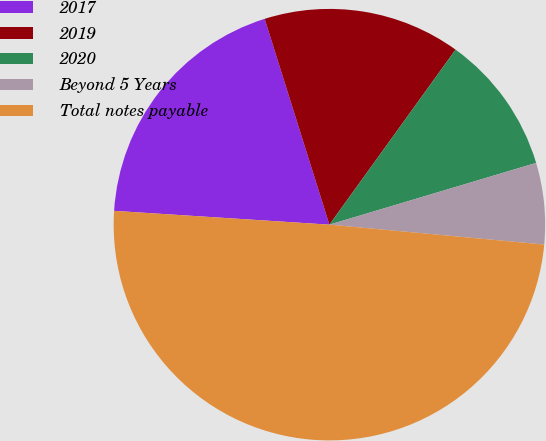Convert chart to OTSL. <chart><loc_0><loc_0><loc_500><loc_500><pie_chart><fcel>2017<fcel>2019<fcel>2020<fcel>Beyond 5 Years<fcel>Total notes payable<nl><fcel>19.13%<fcel>14.79%<fcel>10.44%<fcel>6.09%<fcel>49.55%<nl></chart> 